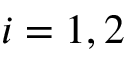Convert formula to latex. <formula><loc_0><loc_0><loc_500><loc_500>i = 1 , 2</formula> 